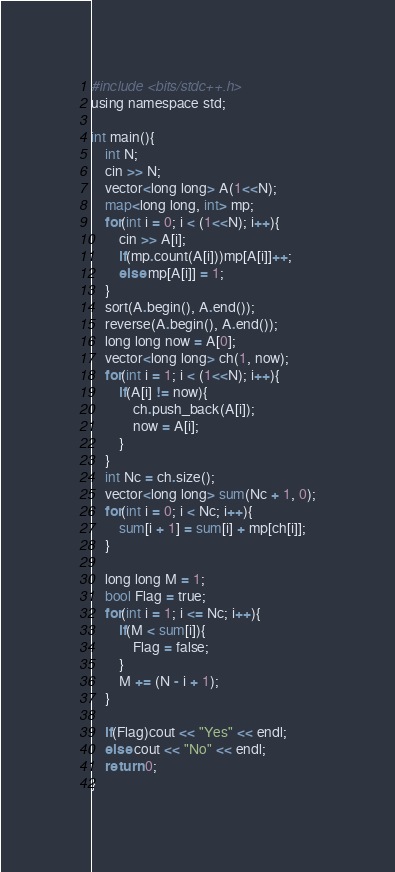Convert code to text. <code><loc_0><loc_0><loc_500><loc_500><_Python_>#include <bits/stdc++.h>
using namespace std;

int main(){
    int N;
    cin >> N;
    vector<long long> A(1<<N);
    map<long long, int> mp;
    for(int i = 0; i < (1<<N); i++){
        cin >> A[i];
        if(mp.count(A[i]))mp[A[i]]++;
        else mp[A[i]] = 1;
    }
    sort(A.begin(), A.end());
    reverse(A.begin(), A.end());
    long long now = A[0];
    vector<long long> ch(1, now);
    for(int i = 1; i < (1<<N); i++){
        if(A[i] != now){
            ch.push_back(A[i]);
            now = A[i];
        }
    }
    int Nc = ch.size();
    vector<long long> sum(Nc + 1, 0);
    for(int i = 0; i < Nc; i++){
        sum[i + 1] = sum[i] + mp[ch[i]];
    }
    
    long long M = 1;
    bool Flag = true;
    for(int i = 1; i <= Nc; i++){
        if(M < sum[i]){
            Flag = false;
        }
        M += (N - i + 1);
    }
    
    if(Flag)cout << "Yes" << endl;
    else cout << "No" << endl;
    return 0;
}</code> 